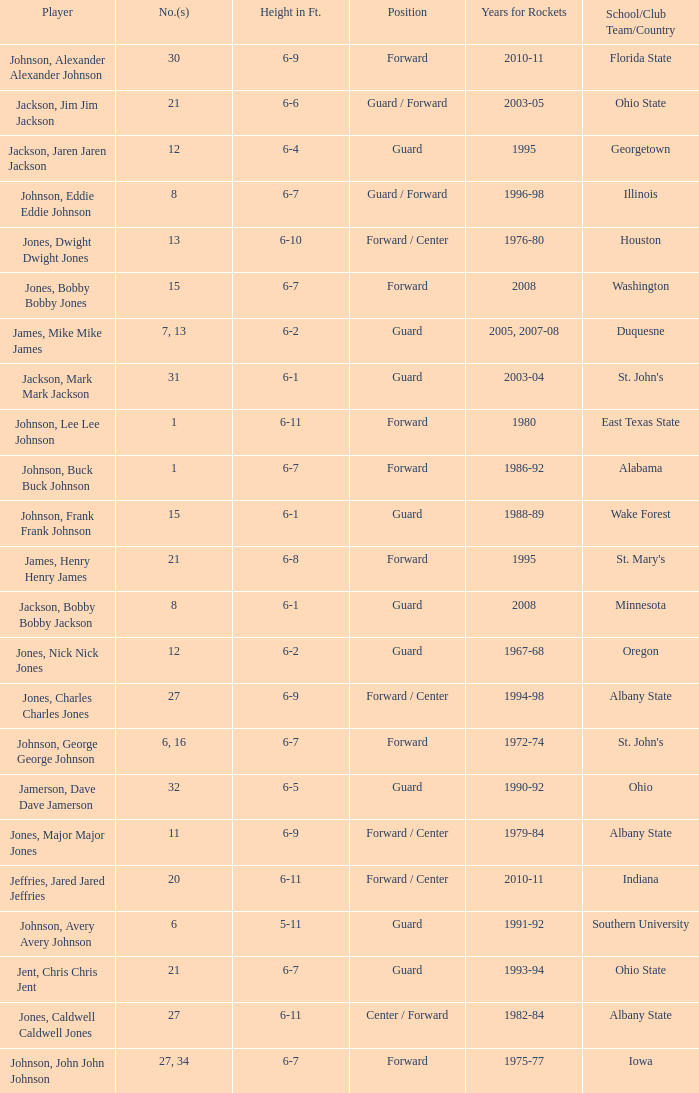Give me the full table as a dictionary. {'header': ['Player', 'No.(s)', 'Height in Ft.', 'Position', 'Years for Rockets', 'School/Club Team/Country'], 'rows': [['Johnson, Alexander Alexander Johnson', '30', '6-9', 'Forward', '2010-11', 'Florida State'], ['Jackson, Jim Jim Jackson', '21', '6-6', 'Guard / Forward', '2003-05', 'Ohio State'], ['Jackson, Jaren Jaren Jackson', '12', '6-4', 'Guard', '1995', 'Georgetown'], ['Johnson, Eddie Eddie Johnson', '8', '6-7', 'Guard / Forward', '1996-98', 'Illinois'], ['Jones, Dwight Dwight Jones', '13', '6-10', 'Forward / Center', '1976-80', 'Houston'], ['Jones, Bobby Bobby Jones', '15', '6-7', 'Forward', '2008', 'Washington'], ['James, Mike Mike James', '7, 13', '6-2', 'Guard', '2005, 2007-08', 'Duquesne'], ['Jackson, Mark Mark Jackson', '31', '6-1', 'Guard', '2003-04', "St. John's"], ['Johnson, Lee Lee Johnson', '1', '6-11', 'Forward', '1980', 'East Texas State'], ['Johnson, Buck Buck Johnson', '1', '6-7', 'Forward', '1986-92', 'Alabama'], ['Johnson, Frank Frank Johnson', '15', '6-1', 'Guard', '1988-89', 'Wake Forest'], ['James, Henry Henry James', '21', '6-8', 'Forward', '1995', "St. Mary's"], ['Jackson, Bobby Bobby Jackson', '8', '6-1', 'Guard', '2008', 'Minnesota'], ['Jones, Nick Nick Jones', '12', '6-2', 'Guard', '1967-68', 'Oregon'], ['Jones, Charles Charles Jones', '27', '6-9', 'Forward / Center', '1994-98', 'Albany State'], ['Johnson, George George Johnson', '6, 16', '6-7', 'Forward', '1972-74', "St. John's"], ['Jamerson, Dave Dave Jamerson', '32', '6-5', 'Guard', '1990-92', 'Ohio'], ['Jones, Major Major Jones', '11', '6-9', 'Forward / Center', '1979-84', 'Albany State'], ['Jeffries, Jared Jared Jeffries', '20', '6-11', 'Forward / Center', '2010-11', 'Indiana'], ['Johnson, Avery Avery Johnson', '6', '5-11', 'Guard', '1991-92', 'Southern University'], ['Jent, Chris Chris Jent', '21', '6-7', 'Guard', '1993-94', 'Ohio State'], ['Jones, Caldwell Caldwell Jones', '27', '6-11', 'Center / Forward', '1982-84', 'Albany State'], ['Johnson, John John Johnson', '27, 34', '6-7', 'Forward', '1975-77', 'Iowa']]} How tall is the player jones, major major jones? 6-9. 